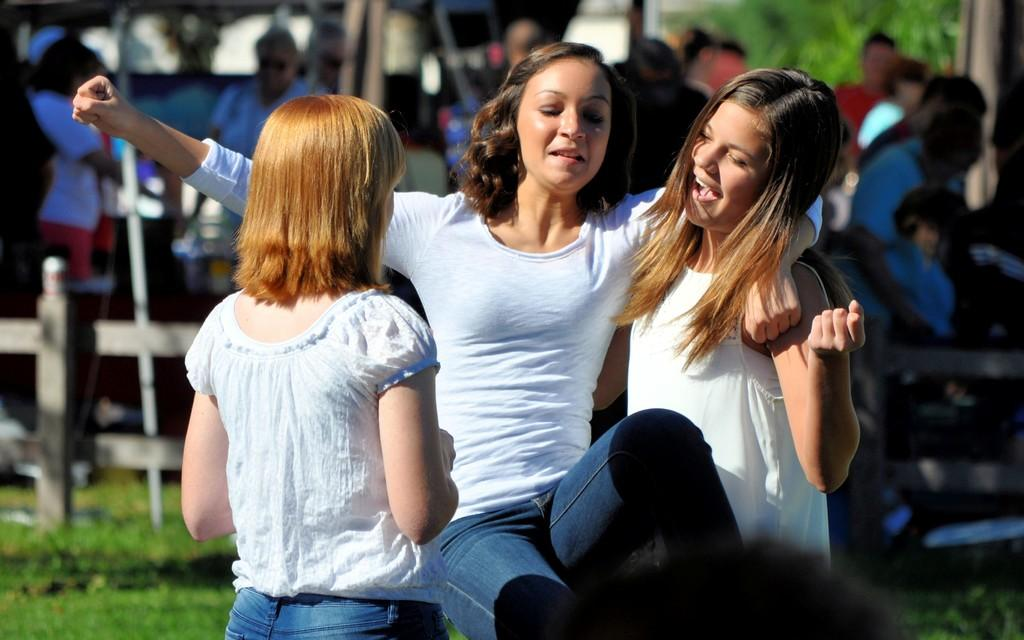Who is present in the image? There is a woman and two children in the image. What is the setting of the image? There is grass visible in the image, suggesting an outdoor setting. How many people are in the group in the image? There is a group of people in the image, consisting of the woman and two children. What objects can be seen in the image? There is a pole, a tree, and a wooden fence in the image. What type of advertisement can be seen on the woman's legs in the image? There is no advertisement visible on the woman's legs in the image. 